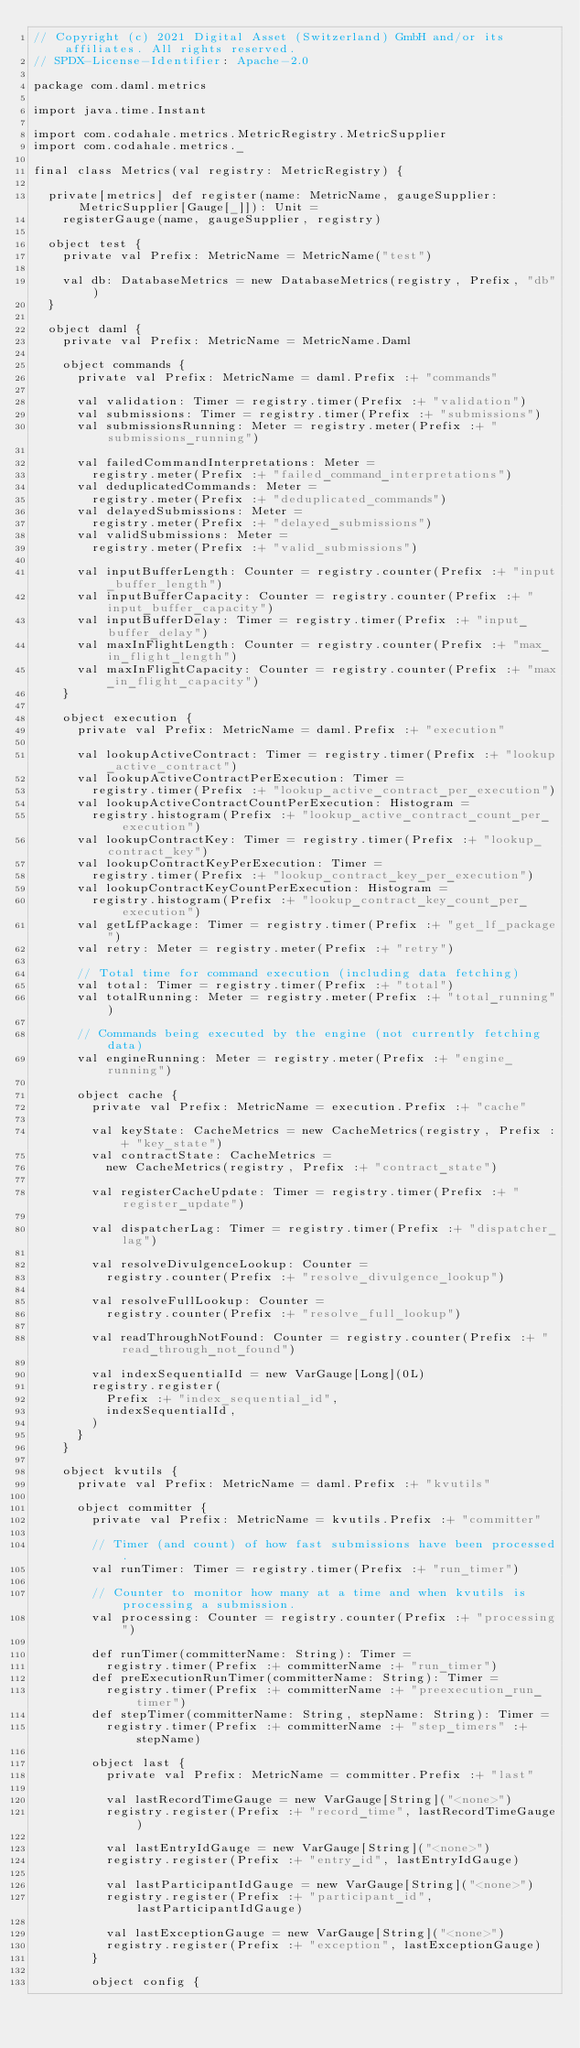Convert code to text. <code><loc_0><loc_0><loc_500><loc_500><_Scala_>// Copyright (c) 2021 Digital Asset (Switzerland) GmbH and/or its affiliates. All rights reserved.
// SPDX-License-Identifier: Apache-2.0

package com.daml.metrics

import java.time.Instant

import com.codahale.metrics.MetricRegistry.MetricSupplier
import com.codahale.metrics._

final class Metrics(val registry: MetricRegistry) {

  private[metrics] def register(name: MetricName, gaugeSupplier: MetricSupplier[Gauge[_]]): Unit =
    registerGauge(name, gaugeSupplier, registry)

  object test {
    private val Prefix: MetricName = MetricName("test")

    val db: DatabaseMetrics = new DatabaseMetrics(registry, Prefix, "db")
  }

  object daml {
    private val Prefix: MetricName = MetricName.Daml

    object commands {
      private val Prefix: MetricName = daml.Prefix :+ "commands"

      val validation: Timer = registry.timer(Prefix :+ "validation")
      val submissions: Timer = registry.timer(Prefix :+ "submissions")
      val submissionsRunning: Meter = registry.meter(Prefix :+ "submissions_running")

      val failedCommandInterpretations: Meter =
        registry.meter(Prefix :+ "failed_command_interpretations")
      val deduplicatedCommands: Meter =
        registry.meter(Prefix :+ "deduplicated_commands")
      val delayedSubmissions: Meter =
        registry.meter(Prefix :+ "delayed_submissions")
      val validSubmissions: Meter =
        registry.meter(Prefix :+ "valid_submissions")

      val inputBufferLength: Counter = registry.counter(Prefix :+ "input_buffer_length")
      val inputBufferCapacity: Counter = registry.counter(Prefix :+ "input_buffer_capacity")
      val inputBufferDelay: Timer = registry.timer(Prefix :+ "input_buffer_delay")
      val maxInFlightLength: Counter = registry.counter(Prefix :+ "max_in_flight_length")
      val maxInFlightCapacity: Counter = registry.counter(Prefix :+ "max_in_flight_capacity")
    }

    object execution {
      private val Prefix: MetricName = daml.Prefix :+ "execution"

      val lookupActiveContract: Timer = registry.timer(Prefix :+ "lookup_active_contract")
      val lookupActiveContractPerExecution: Timer =
        registry.timer(Prefix :+ "lookup_active_contract_per_execution")
      val lookupActiveContractCountPerExecution: Histogram =
        registry.histogram(Prefix :+ "lookup_active_contract_count_per_execution")
      val lookupContractKey: Timer = registry.timer(Prefix :+ "lookup_contract_key")
      val lookupContractKeyPerExecution: Timer =
        registry.timer(Prefix :+ "lookup_contract_key_per_execution")
      val lookupContractKeyCountPerExecution: Histogram =
        registry.histogram(Prefix :+ "lookup_contract_key_count_per_execution")
      val getLfPackage: Timer = registry.timer(Prefix :+ "get_lf_package")
      val retry: Meter = registry.meter(Prefix :+ "retry")

      // Total time for command execution (including data fetching)
      val total: Timer = registry.timer(Prefix :+ "total")
      val totalRunning: Meter = registry.meter(Prefix :+ "total_running")

      // Commands being executed by the engine (not currently fetching data)
      val engineRunning: Meter = registry.meter(Prefix :+ "engine_running")

      object cache {
        private val Prefix: MetricName = execution.Prefix :+ "cache"

        val keyState: CacheMetrics = new CacheMetrics(registry, Prefix :+ "key_state")
        val contractState: CacheMetrics =
          new CacheMetrics(registry, Prefix :+ "contract_state")

        val registerCacheUpdate: Timer = registry.timer(Prefix :+ "register_update")

        val dispatcherLag: Timer = registry.timer(Prefix :+ "dispatcher_lag")

        val resolveDivulgenceLookup: Counter =
          registry.counter(Prefix :+ "resolve_divulgence_lookup")

        val resolveFullLookup: Counter =
          registry.counter(Prefix :+ "resolve_full_lookup")

        val readThroughNotFound: Counter = registry.counter(Prefix :+ "read_through_not_found")

        val indexSequentialId = new VarGauge[Long](0L)
        registry.register(
          Prefix :+ "index_sequential_id",
          indexSequentialId,
        )
      }
    }

    object kvutils {
      private val Prefix: MetricName = daml.Prefix :+ "kvutils"

      object committer {
        private val Prefix: MetricName = kvutils.Prefix :+ "committer"

        // Timer (and count) of how fast submissions have been processed.
        val runTimer: Timer = registry.timer(Prefix :+ "run_timer")

        // Counter to monitor how many at a time and when kvutils is processing a submission.
        val processing: Counter = registry.counter(Prefix :+ "processing")

        def runTimer(committerName: String): Timer =
          registry.timer(Prefix :+ committerName :+ "run_timer")
        def preExecutionRunTimer(committerName: String): Timer =
          registry.timer(Prefix :+ committerName :+ "preexecution_run_timer")
        def stepTimer(committerName: String, stepName: String): Timer =
          registry.timer(Prefix :+ committerName :+ "step_timers" :+ stepName)

        object last {
          private val Prefix: MetricName = committer.Prefix :+ "last"

          val lastRecordTimeGauge = new VarGauge[String]("<none>")
          registry.register(Prefix :+ "record_time", lastRecordTimeGauge)

          val lastEntryIdGauge = new VarGauge[String]("<none>")
          registry.register(Prefix :+ "entry_id", lastEntryIdGauge)

          val lastParticipantIdGauge = new VarGauge[String]("<none>")
          registry.register(Prefix :+ "participant_id", lastParticipantIdGauge)

          val lastExceptionGauge = new VarGauge[String]("<none>")
          registry.register(Prefix :+ "exception", lastExceptionGauge)
        }

        object config {</code> 